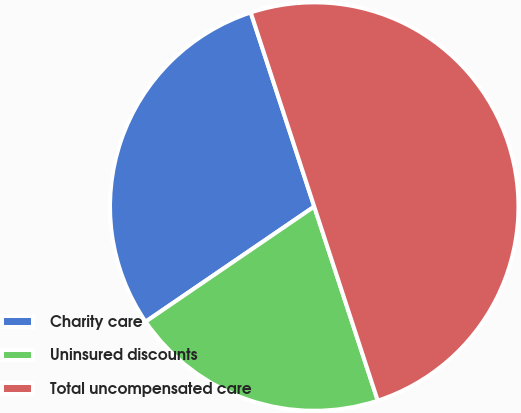Convert chart. <chart><loc_0><loc_0><loc_500><loc_500><pie_chart><fcel>Charity care<fcel>Uninsured discounts<fcel>Total uncompensated care<nl><fcel>29.5%<fcel>20.5%<fcel>50.0%<nl></chart> 